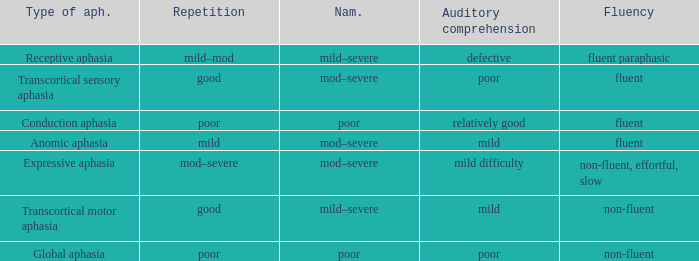Name the naming for fluent and poor comprehension Mod–severe. 